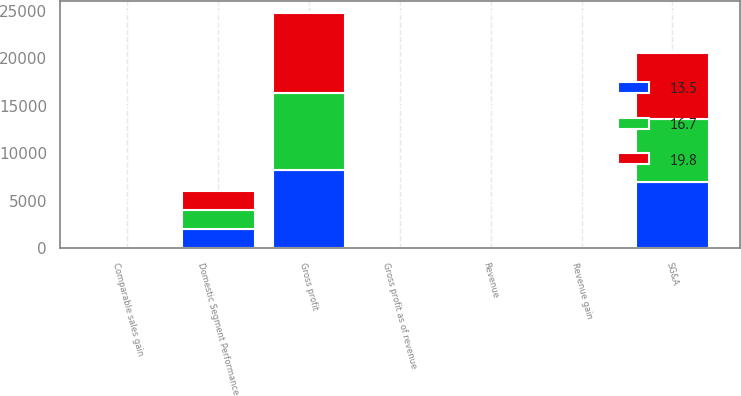Convert chart to OTSL. <chart><loc_0><loc_0><loc_500><loc_500><stacked_bar_chart><ecel><fcel>Domestic Segment Performance<fcel>Revenue<fcel>Revenue gain<fcel>Comparable sales gain<fcel>Gross profit<fcel>Gross profit as of revenue<fcel>SG&A<nl><fcel>19.8<fcel>2016<fcel>23.1<fcel>0.9<fcel>0.1<fcel>8484<fcel>23.3<fcel>6897<nl><fcel>16.7<fcel>2015<fcel>23.1<fcel>0.6<fcel>0.5<fcel>8080<fcel>22.4<fcel>6639<nl><fcel>13.5<fcel>2014<fcel>23.1<fcel>7.9<fcel>0.4<fcel>8274<fcel>23.1<fcel>7006<nl></chart> 